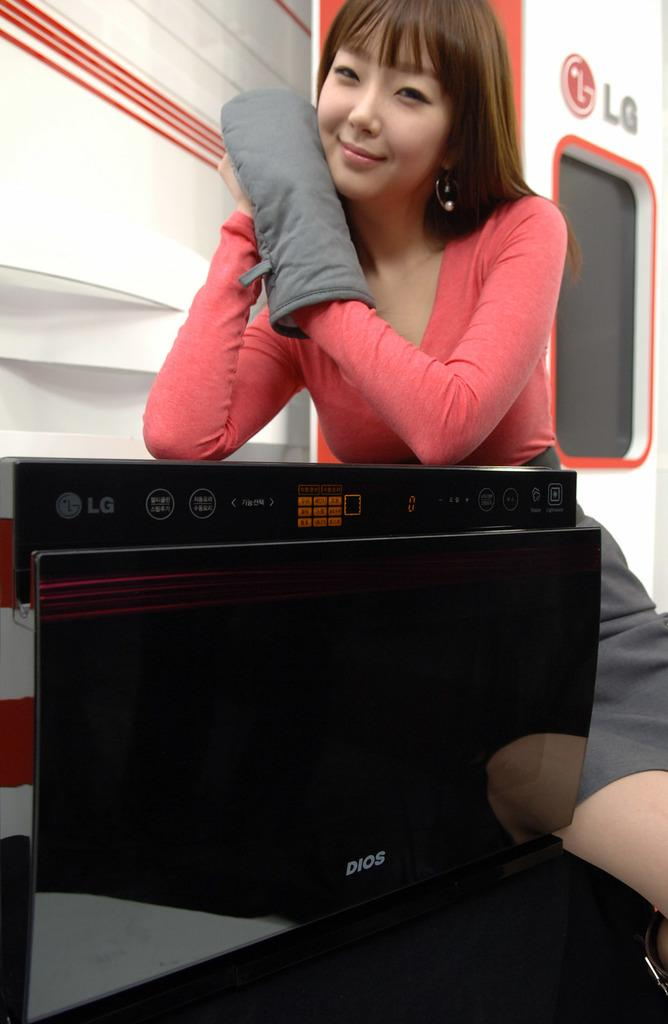Provide a one-sentence caption for the provided image. A woman sits with an LG appliance behind an LG branded door. 